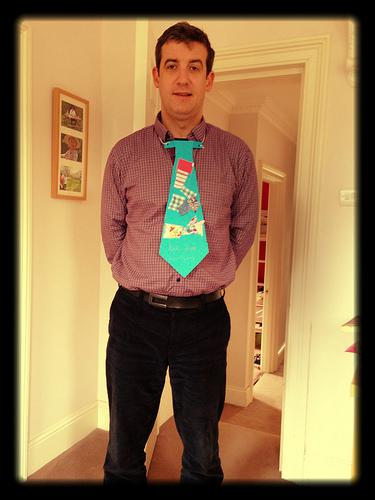Question: what is the color of the floor?
Choices:
A. Blue.
B. Yellow.
C. Gray.
D. Brown.
Answer with the letter. Answer: D Question: what is the color of the shirt?
Choices:
A. Blue.
B. Purple.
C. Pink.
D. Black.
Answer with the letter. Answer: B Question: what is the color of the pant?
Choices:
A. Blue.
B. Green.
C. Black.
D. Gray.
Answer with the letter. Answer: C Question: what is the color of the tie?
Choices:
A. Purple.
B. Blue.
C. Pink.
D. Brown.
Answer with the letter. Answer: B 